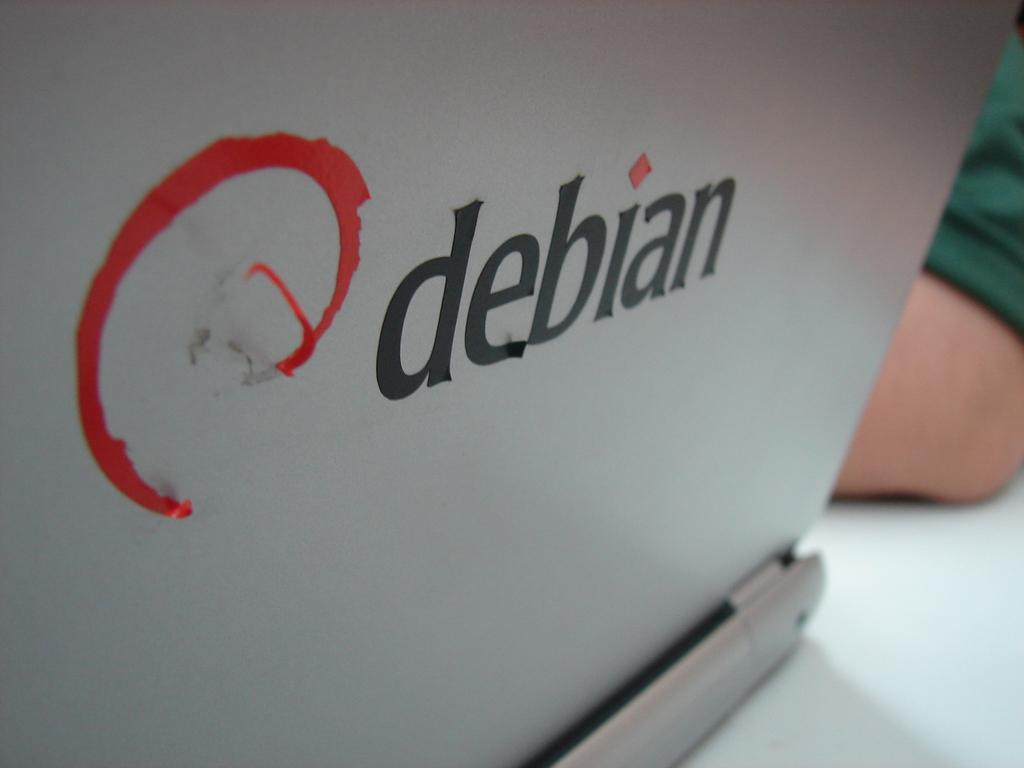What electronic device is present in the image? There is a laptop in the image. What can be seen on the laptop's surface? Text is visible on the laptop's surface. Can you describe anything in the background of the image? There is a hand of a person in the background of the image. What type of shade is being used to treat the disease on the laptop's screen? There is no shade or disease present on the laptop's screen in the image. 